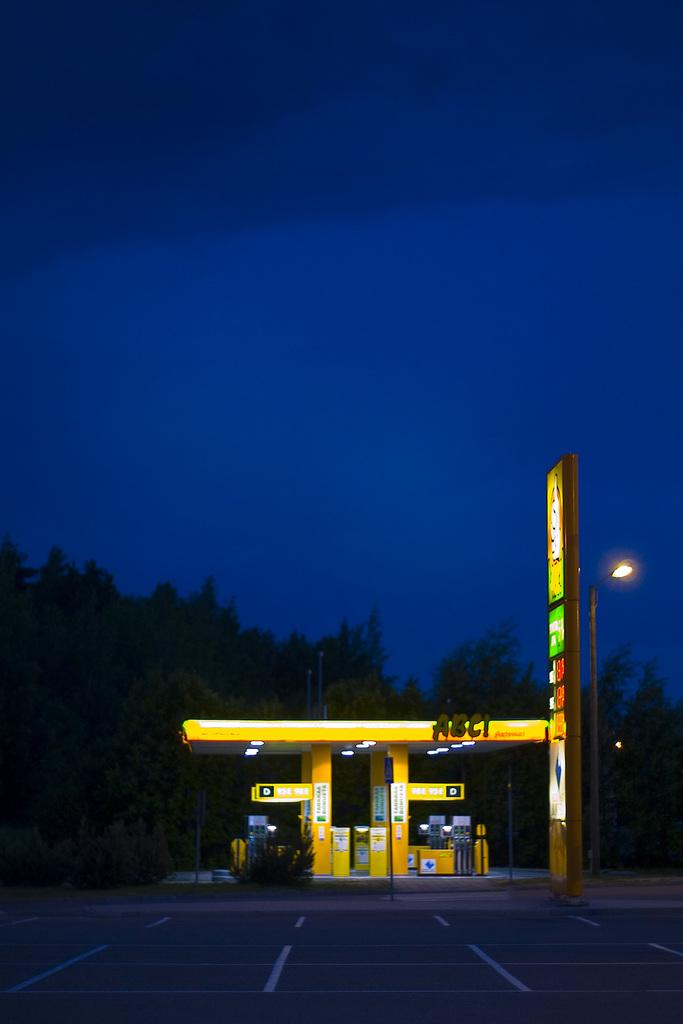What is the name of this gas station?
Your answer should be very brief. Abc!. 